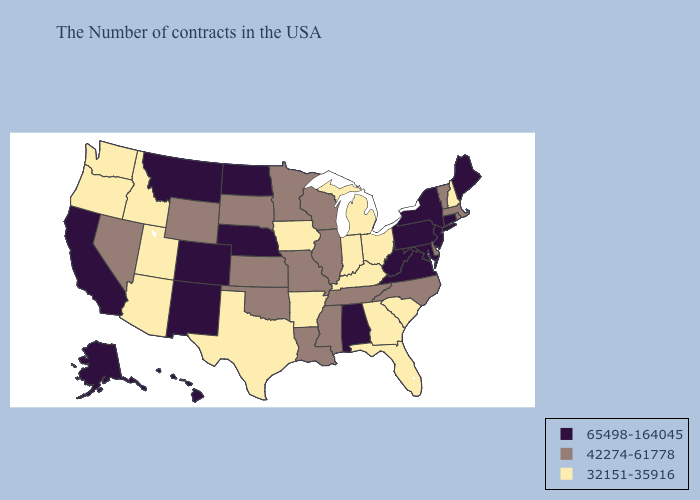Does Missouri have a lower value than Indiana?
Keep it brief. No. Name the states that have a value in the range 42274-61778?
Short answer required. Massachusetts, Rhode Island, Vermont, Delaware, North Carolina, Tennessee, Wisconsin, Illinois, Mississippi, Louisiana, Missouri, Minnesota, Kansas, Oklahoma, South Dakota, Wyoming, Nevada. What is the lowest value in the Northeast?
Be succinct. 32151-35916. Name the states that have a value in the range 32151-35916?
Keep it brief. New Hampshire, South Carolina, Ohio, Florida, Georgia, Michigan, Kentucky, Indiana, Arkansas, Iowa, Texas, Utah, Arizona, Idaho, Washington, Oregon. Name the states that have a value in the range 32151-35916?
Be succinct. New Hampshire, South Carolina, Ohio, Florida, Georgia, Michigan, Kentucky, Indiana, Arkansas, Iowa, Texas, Utah, Arizona, Idaho, Washington, Oregon. Name the states that have a value in the range 32151-35916?
Concise answer only. New Hampshire, South Carolina, Ohio, Florida, Georgia, Michigan, Kentucky, Indiana, Arkansas, Iowa, Texas, Utah, Arizona, Idaho, Washington, Oregon. Does Colorado have the highest value in the West?
Concise answer only. Yes. Does Massachusetts have a lower value than Nevada?
Quick response, please. No. What is the value of South Carolina?
Short answer required. 32151-35916. Name the states that have a value in the range 32151-35916?
Write a very short answer. New Hampshire, South Carolina, Ohio, Florida, Georgia, Michigan, Kentucky, Indiana, Arkansas, Iowa, Texas, Utah, Arizona, Idaho, Washington, Oregon. Name the states that have a value in the range 32151-35916?
Write a very short answer. New Hampshire, South Carolina, Ohio, Florida, Georgia, Michigan, Kentucky, Indiana, Arkansas, Iowa, Texas, Utah, Arizona, Idaho, Washington, Oregon. Name the states that have a value in the range 65498-164045?
Answer briefly. Maine, Connecticut, New York, New Jersey, Maryland, Pennsylvania, Virginia, West Virginia, Alabama, Nebraska, North Dakota, Colorado, New Mexico, Montana, California, Alaska, Hawaii. What is the lowest value in the USA?
Concise answer only. 32151-35916. Does Kansas have the lowest value in the USA?
Give a very brief answer. No. Does Michigan have the lowest value in the MidWest?
Give a very brief answer. Yes. 